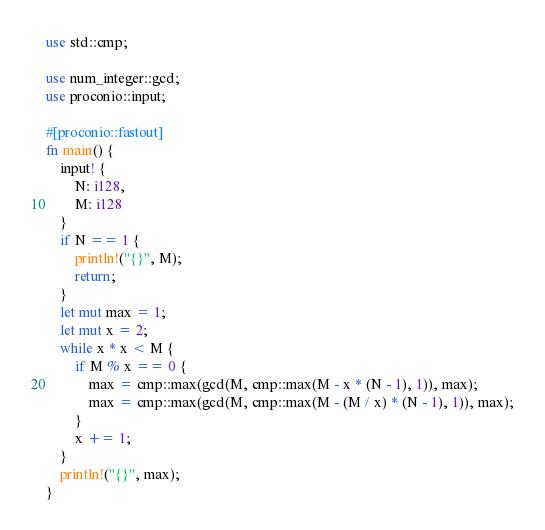<code> <loc_0><loc_0><loc_500><loc_500><_Rust_>use std::cmp;

use num_integer::gcd;
use proconio::input;

#[proconio::fastout]
fn main() {
    input! {
        N: i128,
        M: i128
    }
    if N == 1 {
        println!("{}", M);
        return;
    }
    let mut max = 1;
    let mut x = 2;
    while x * x < M {
        if M % x == 0 {
            max = cmp::max(gcd(M, cmp::max(M - x * (N - 1), 1)), max);
            max = cmp::max(gcd(M, cmp::max(M - (M / x) * (N - 1), 1)), max);
        }
        x += 1;
    }
    println!("{}", max);
}
</code> 